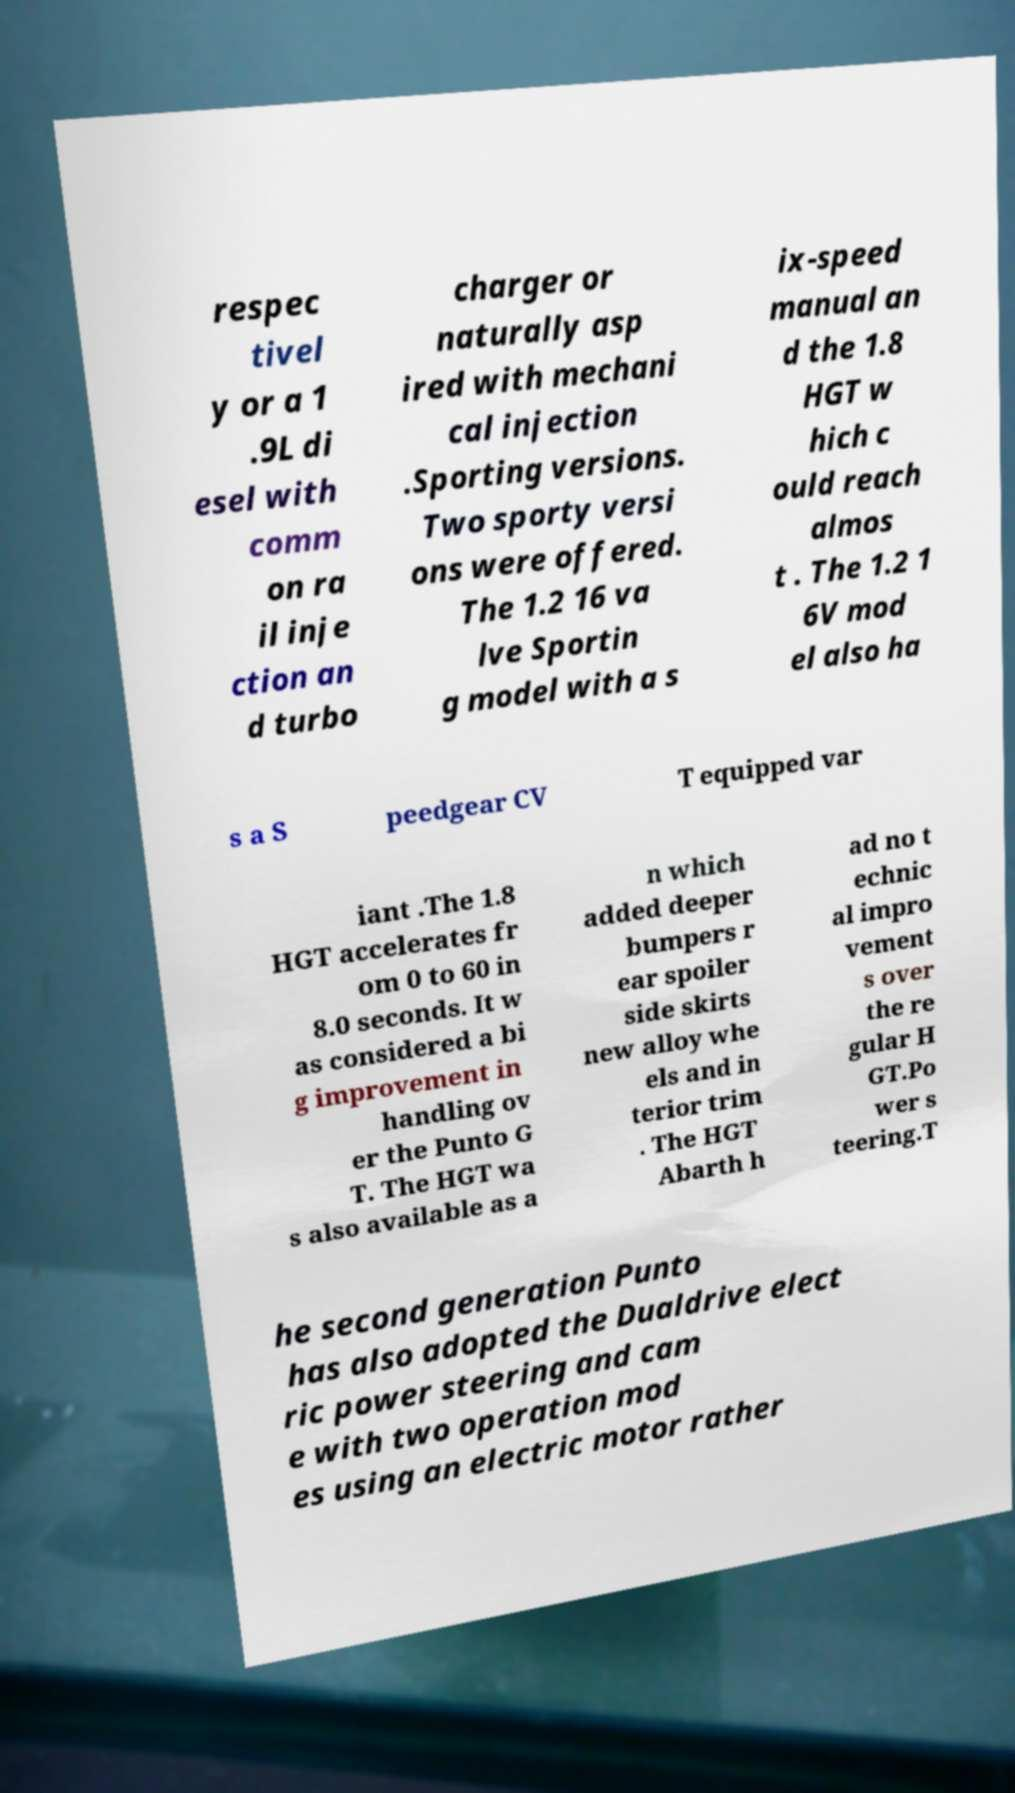There's text embedded in this image that I need extracted. Can you transcribe it verbatim? respec tivel y or a 1 .9L di esel with comm on ra il inje ction an d turbo charger or naturally asp ired with mechani cal injection .Sporting versions. Two sporty versi ons were offered. The 1.2 16 va lve Sportin g model with a s ix-speed manual an d the 1.8 HGT w hich c ould reach almos t . The 1.2 1 6V mod el also ha s a S peedgear CV T equipped var iant .The 1.8 HGT accelerates fr om 0 to 60 in 8.0 seconds. It w as considered a bi g improvement in handling ov er the Punto G T. The HGT wa s also available as a n which added deeper bumpers r ear spoiler side skirts new alloy whe els and in terior trim . The HGT Abarth h ad no t echnic al impro vement s over the re gular H GT.Po wer s teering.T he second generation Punto has also adopted the Dualdrive elect ric power steering and cam e with two operation mod es using an electric motor rather 